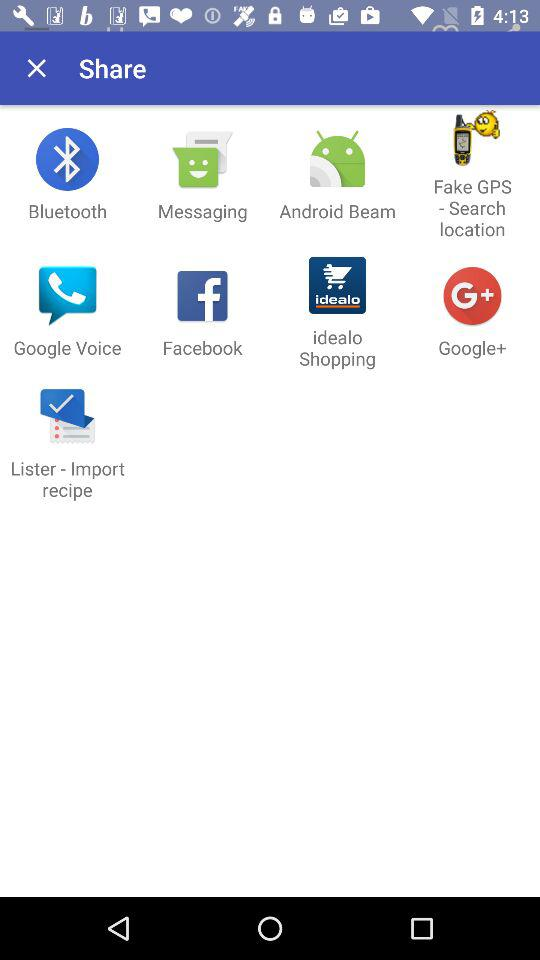Through which applications can the content be shared? The content can be shared through "Bluetooth", "Messaging", "Android Beam", "Fake GPS - Search location", "Google Voice", "Facebook", "idealo Shopping", "Google+" and "Lister - Import recipe". 